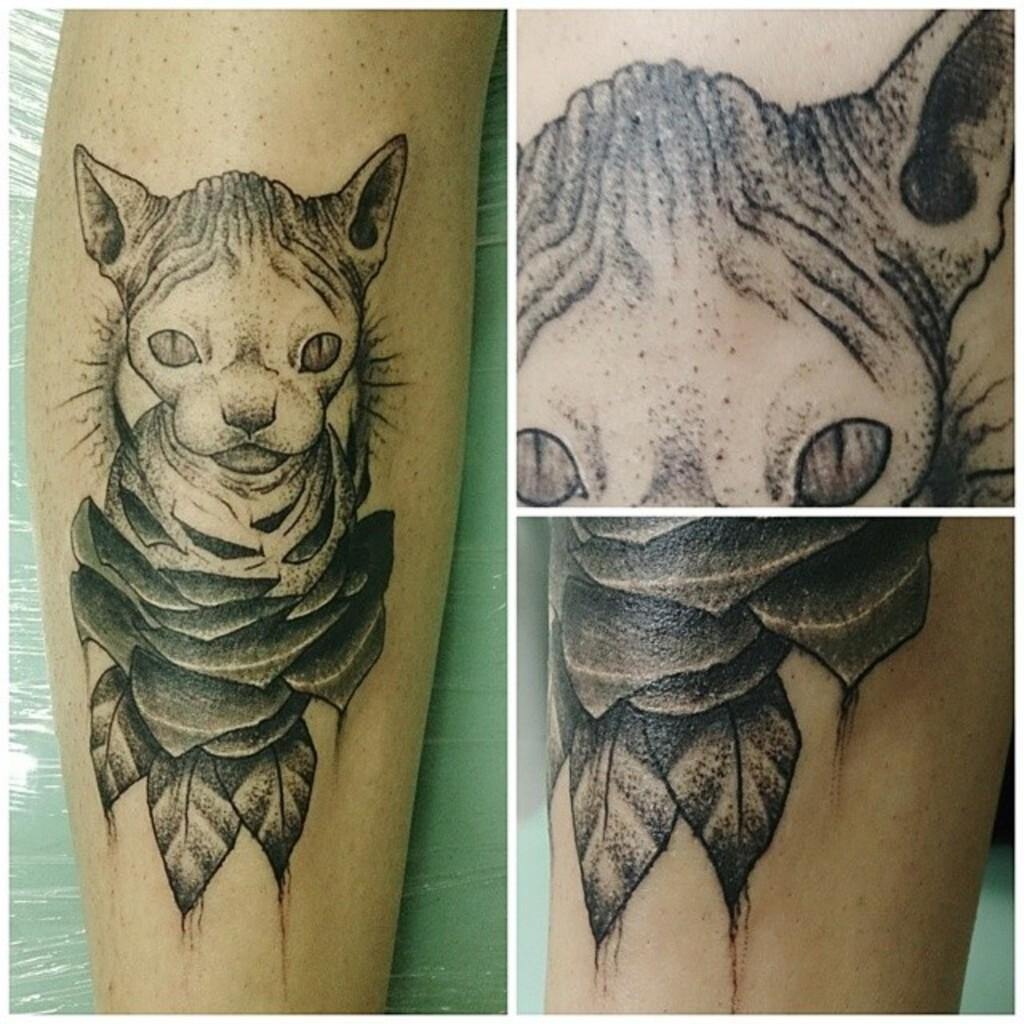Can you describe this image briefly? In this image there is one person's hand is visible and this is a collage, on the person's hand there is one tattoo. 